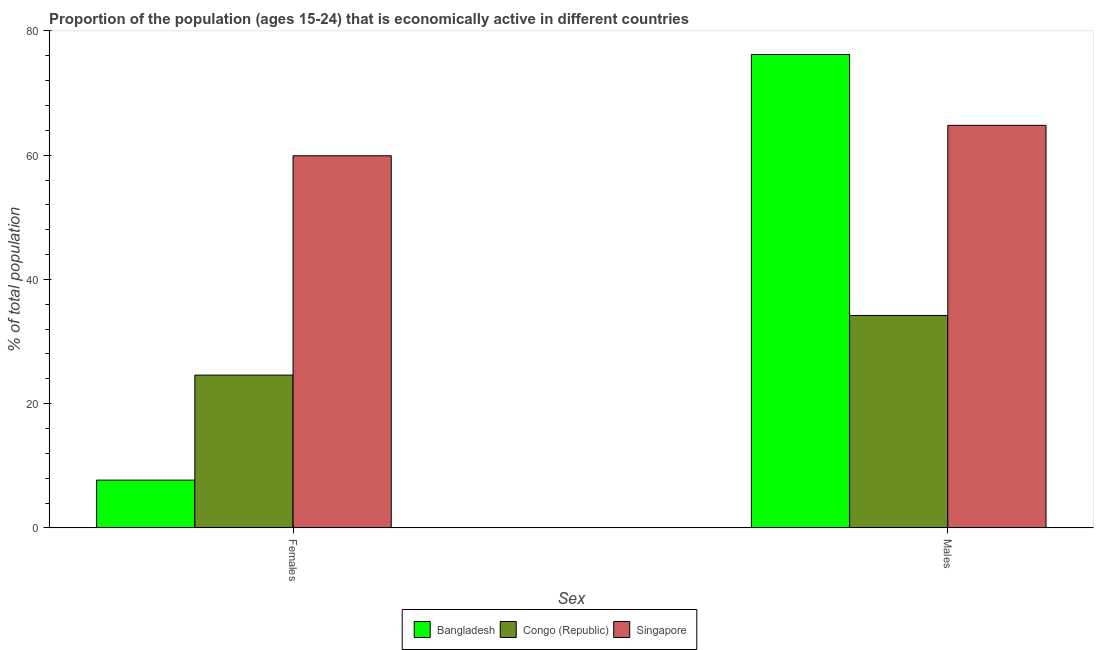How many groups of bars are there?
Make the answer very short. 2. Are the number of bars per tick equal to the number of legend labels?
Provide a short and direct response. Yes. Are the number of bars on each tick of the X-axis equal?
Offer a very short reply. Yes. What is the label of the 1st group of bars from the left?
Give a very brief answer. Females. What is the percentage of economically active male population in Singapore?
Offer a very short reply. 64.8. Across all countries, what is the maximum percentage of economically active male population?
Your answer should be compact. 76.2. Across all countries, what is the minimum percentage of economically active male population?
Provide a succinct answer. 34.2. In which country was the percentage of economically active male population maximum?
Ensure brevity in your answer.  Bangladesh. In which country was the percentage of economically active male population minimum?
Your answer should be compact. Congo (Republic). What is the total percentage of economically active male population in the graph?
Provide a succinct answer. 175.2. What is the difference between the percentage of economically active female population in Congo (Republic) and that in Bangladesh?
Provide a short and direct response. 16.9. What is the difference between the percentage of economically active female population in Congo (Republic) and the percentage of economically active male population in Bangladesh?
Ensure brevity in your answer.  -51.6. What is the average percentage of economically active male population per country?
Your answer should be very brief. 58.4. What is the difference between the percentage of economically active female population and percentage of economically active male population in Singapore?
Offer a terse response. -4.9. In how many countries, is the percentage of economically active male population greater than 16 %?
Provide a short and direct response. 3. What is the ratio of the percentage of economically active female population in Congo (Republic) to that in Bangladesh?
Provide a succinct answer. 3.19. Is the percentage of economically active male population in Congo (Republic) less than that in Singapore?
Give a very brief answer. Yes. In how many countries, is the percentage of economically active female population greater than the average percentage of economically active female population taken over all countries?
Offer a very short reply. 1. What does the 3rd bar from the left in Females represents?
Offer a terse response. Singapore. What does the 3rd bar from the right in Females represents?
Offer a terse response. Bangladesh. Are all the bars in the graph horizontal?
Give a very brief answer. No. What is the difference between two consecutive major ticks on the Y-axis?
Offer a very short reply. 20. Does the graph contain any zero values?
Offer a terse response. No. Where does the legend appear in the graph?
Give a very brief answer. Bottom center. How are the legend labels stacked?
Your response must be concise. Horizontal. What is the title of the graph?
Offer a terse response. Proportion of the population (ages 15-24) that is economically active in different countries. Does "New Caledonia" appear as one of the legend labels in the graph?
Your response must be concise. No. What is the label or title of the X-axis?
Your answer should be very brief. Sex. What is the label or title of the Y-axis?
Provide a succinct answer. % of total population. What is the % of total population of Bangladesh in Females?
Offer a very short reply. 7.7. What is the % of total population in Congo (Republic) in Females?
Offer a terse response. 24.6. What is the % of total population in Singapore in Females?
Ensure brevity in your answer.  59.9. What is the % of total population of Bangladesh in Males?
Provide a short and direct response. 76.2. What is the % of total population in Congo (Republic) in Males?
Your response must be concise. 34.2. What is the % of total population of Singapore in Males?
Your answer should be compact. 64.8. Across all Sex, what is the maximum % of total population of Bangladesh?
Your answer should be compact. 76.2. Across all Sex, what is the maximum % of total population in Congo (Republic)?
Ensure brevity in your answer.  34.2. Across all Sex, what is the maximum % of total population in Singapore?
Your answer should be very brief. 64.8. Across all Sex, what is the minimum % of total population of Bangladesh?
Offer a very short reply. 7.7. Across all Sex, what is the minimum % of total population in Congo (Republic)?
Offer a terse response. 24.6. Across all Sex, what is the minimum % of total population in Singapore?
Ensure brevity in your answer.  59.9. What is the total % of total population of Bangladesh in the graph?
Give a very brief answer. 83.9. What is the total % of total population in Congo (Republic) in the graph?
Provide a short and direct response. 58.8. What is the total % of total population in Singapore in the graph?
Your answer should be very brief. 124.7. What is the difference between the % of total population of Bangladesh in Females and that in Males?
Offer a very short reply. -68.5. What is the difference between the % of total population in Singapore in Females and that in Males?
Provide a succinct answer. -4.9. What is the difference between the % of total population of Bangladesh in Females and the % of total population of Congo (Republic) in Males?
Keep it short and to the point. -26.5. What is the difference between the % of total population of Bangladesh in Females and the % of total population of Singapore in Males?
Your answer should be very brief. -57.1. What is the difference between the % of total population in Congo (Republic) in Females and the % of total population in Singapore in Males?
Provide a short and direct response. -40.2. What is the average % of total population in Bangladesh per Sex?
Your answer should be very brief. 41.95. What is the average % of total population in Congo (Republic) per Sex?
Offer a very short reply. 29.4. What is the average % of total population of Singapore per Sex?
Keep it short and to the point. 62.35. What is the difference between the % of total population of Bangladesh and % of total population of Congo (Republic) in Females?
Your answer should be very brief. -16.9. What is the difference between the % of total population of Bangladesh and % of total population of Singapore in Females?
Ensure brevity in your answer.  -52.2. What is the difference between the % of total population in Congo (Republic) and % of total population in Singapore in Females?
Your answer should be very brief. -35.3. What is the difference between the % of total population in Bangladesh and % of total population in Congo (Republic) in Males?
Keep it short and to the point. 42. What is the difference between the % of total population of Bangladesh and % of total population of Singapore in Males?
Offer a very short reply. 11.4. What is the difference between the % of total population of Congo (Republic) and % of total population of Singapore in Males?
Give a very brief answer. -30.6. What is the ratio of the % of total population in Bangladesh in Females to that in Males?
Keep it short and to the point. 0.1. What is the ratio of the % of total population in Congo (Republic) in Females to that in Males?
Offer a terse response. 0.72. What is the ratio of the % of total population in Singapore in Females to that in Males?
Give a very brief answer. 0.92. What is the difference between the highest and the second highest % of total population in Bangladesh?
Provide a short and direct response. 68.5. What is the difference between the highest and the second highest % of total population of Congo (Republic)?
Keep it short and to the point. 9.6. What is the difference between the highest and the lowest % of total population of Bangladesh?
Your answer should be very brief. 68.5. What is the difference between the highest and the lowest % of total population in Congo (Republic)?
Provide a succinct answer. 9.6. 